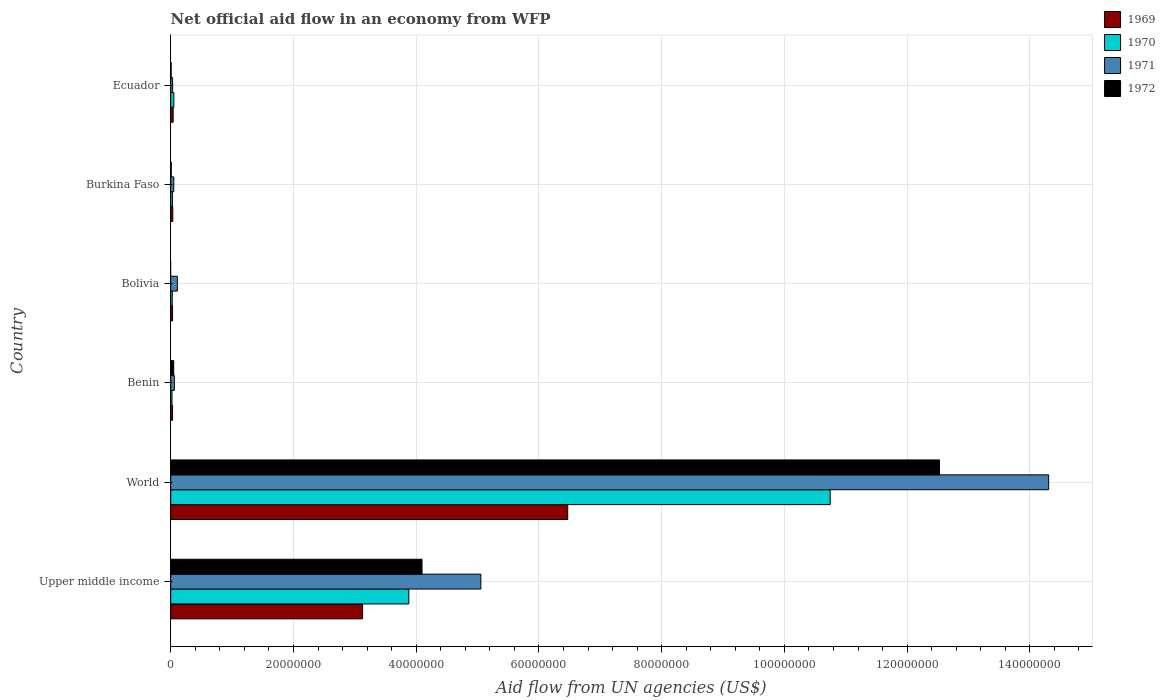Are the number of bars per tick equal to the number of legend labels?
Provide a succinct answer. No. Are the number of bars on each tick of the Y-axis equal?
Make the answer very short. No. How many bars are there on the 4th tick from the top?
Provide a succinct answer. 4. How many bars are there on the 2nd tick from the bottom?
Keep it short and to the point. 4. What is the net official aid flow in 1972 in Burkina Faso?
Give a very brief answer. 9.00e+04. Across all countries, what is the maximum net official aid flow in 1970?
Provide a short and direct response. 1.07e+08. Across all countries, what is the minimum net official aid flow in 1969?
Ensure brevity in your answer.  3.00e+05. What is the total net official aid flow in 1972 in the graph?
Provide a short and direct response. 1.67e+08. What is the difference between the net official aid flow in 1972 in Burkina Faso and that in World?
Your response must be concise. -1.25e+08. What is the difference between the net official aid flow in 1969 in Bolivia and the net official aid flow in 1971 in Burkina Faso?
Your response must be concise. -2.00e+05. What is the average net official aid flow in 1970 per country?
Your answer should be compact. 2.46e+07. In how many countries, is the net official aid flow in 1971 greater than 32000000 US$?
Provide a succinct answer. 2. What is the ratio of the net official aid flow in 1970 in Burkina Faso to that in Ecuador?
Provide a succinct answer. 0.55. Is the net official aid flow in 1970 in Benin less than that in Ecuador?
Your response must be concise. Yes. What is the difference between the highest and the second highest net official aid flow in 1972?
Your answer should be compact. 8.43e+07. What is the difference between the highest and the lowest net official aid flow in 1969?
Make the answer very short. 6.44e+07. Are all the bars in the graph horizontal?
Your response must be concise. Yes. Are the values on the major ticks of X-axis written in scientific E-notation?
Make the answer very short. No. How many legend labels are there?
Keep it short and to the point. 4. What is the title of the graph?
Make the answer very short. Net official aid flow in an economy from WFP. What is the label or title of the X-axis?
Your answer should be compact. Aid flow from UN agencies (US$). What is the label or title of the Y-axis?
Ensure brevity in your answer.  Country. What is the Aid flow from UN agencies (US$) in 1969 in Upper middle income?
Provide a short and direct response. 3.13e+07. What is the Aid flow from UN agencies (US$) of 1970 in Upper middle income?
Your answer should be very brief. 3.88e+07. What is the Aid flow from UN agencies (US$) of 1971 in Upper middle income?
Your answer should be very brief. 5.05e+07. What is the Aid flow from UN agencies (US$) of 1972 in Upper middle income?
Make the answer very short. 4.10e+07. What is the Aid flow from UN agencies (US$) in 1969 in World?
Provide a succinct answer. 6.47e+07. What is the Aid flow from UN agencies (US$) in 1970 in World?
Provide a short and direct response. 1.07e+08. What is the Aid flow from UN agencies (US$) of 1971 in World?
Your answer should be very brief. 1.43e+08. What is the Aid flow from UN agencies (US$) of 1972 in World?
Give a very brief answer. 1.25e+08. What is the Aid flow from UN agencies (US$) in 1969 in Benin?
Offer a very short reply. 3.00e+05. What is the Aid flow from UN agencies (US$) in 1970 in Benin?
Your answer should be very brief. 2.10e+05. What is the Aid flow from UN agencies (US$) of 1971 in Benin?
Your response must be concise. 5.90e+05. What is the Aid flow from UN agencies (US$) of 1969 in Bolivia?
Make the answer very short. 3.00e+05. What is the Aid flow from UN agencies (US$) in 1971 in Bolivia?
Your answer should be compact. 1.08e+06. What is the Aid flow from UN agencies (US$) of 1970 in Burkina Faso?
Offer a very short reply. 2.80e+05. What is the Aid flow from UN agencies (US$) in 1969 in Ecuador?
Make the answer very short. 4.00e+05. What is the Aid flow from UN agencies (US$) of 1970 in Ecuador?
Your answer should be very brief. 5.10e+05. What is the Aid flow from UN agencies (US$) in 1972 in Ecuador?
Your response must be concise. 7.00e+04. Across all countries, what is the maximum Aid flow from UN agencies (US$) in 1969?
Provide a short and direct response. 6.47e+07. Across all countries, what is the maximum Aid flow from UN agencies (US$) in 1970?
Ensure brevity in your answer.  1.07e+08. Across all countries, what is the maximum Aid flow from UN agencies (US$) in 1971?
Provide a succinct answer. 1.43e+08. Across all countries, what is the maximum Aid flow from UN agencies (US$) in 1972?
Your response must be concise. 1.25e+08. Across all countries, what is the minimum Aid flow from UN agencies (US$) in 1969?
Make the answer very short. 3.00e+05. Across all countries, what is the minimum Aid flow from UN agencies (US$) of 1970?
Offer a very short reply. 2.10e+05. Across all countries, what is the minimum Aid flow from UN agencies (US$) of 1971?
Make the answer very short. 3.10e+05. What is the total Aid flow from UN agencies (US$) in 1969 in the graph?
Provide a succinct answer. 9.73e+07. What is the total Aid flow from UN agencies (US$) in 1970 in the graph?
Make the answer very short. 1.48e+08. What is the total Aid flow from UN agencies (US$) of 1971 in the graph?
Give a very brief answer. 1.96e+08. What is the total Aid flow from UN agencies (US$) of 1972 in the graph?
Your response must be concise. 1.67e+08. What is the difference between the Aid flow from UN agencies (US$) in 1969 in Upper middle income and that in World?
Keep it short and to the point. -3.34e+07. What is the difference between the Aid flow from UN agencies (US$) in 1970 in Upper middle income and that in World?
Make the answer very short. -6.87e+07. What is the difference between the Aid flow from UN agencies (US$) of 1971 in Upper middle income and that in World?
Offer a very short reply. -9.25e+07. What is the difference between the Aid flow from UN agencies (US$) of 1972 in Upper middle income and that in World?
Your answer should be compact. -8.43e+07. What is the difference between the Aid flow from UN agencies (US$) of 1969 in Upper middle income and that in Benin?
Your response must be concise. 3.10e+07. What is the difference between the Aid flow from UN agencies (US$) of 1970 in Upper middle income and that in Benin?
Offer a very short reply. 3.86e+07. What is the difference between the Aid flow from UN agencies (US$) in 1971 in Upper middle income and that in Benin?
Your answer should be very brief. 5.00e+07. What is the difference between the Aid flow from UN agencies (US$) of 1972 in Upper middle income and that in Benin?
Your response must be concise. 4.05e+07. What is the difference between the Aid flow from UN agencies (US$) of 1969 in Upper middle income and that in Bolivia?
Make the answer very short. 3.10e+07. What is the difference between the Aid flow from UN agencies (US$) in 1970 in Upper middle income and that in Bolivia?
Your answer should be very brief. 3.86e+07. What is the difference between the Aid flow from UN agencies (US$) in 1971 in Upper middle income and that in Bolivia?
Your answer should be very brief. 4.95e+07. What is the difference between the Aid flow from UN agencies (US$) of 1969 in Upper middle income and that in Burkina Faso?
Make the answer very short. 3.09e+07. What is the difference between the Aid flow from UN agencies (US$) of 1970 in Upper middle income and that in Burkina Faso?
Keep it short and to the point. 3.85e+07. What is the difference between the Aid flow from UN agencies (US$) of 1971 in Upper middle income and that in Burkina Faso?
Offer a very short reply. 5.00e+07. What is the difference between the Aid flow from UN agencies (US$) of 1972 in Upper middle income and that in Burkina Faso?
Ensure brevity in your answer.  4.09e+07. What is the difference between the Aid flow from UN agencies (US$) of 1969 in Upper middle income and that in Ecuador?
Your answer should be very brief. 3.09e+07. What is the difference between the Aid flow from UN agencies (US$) in 1970 in Upper middle income and that in Ecuador?
Offer a terse response. 3.83e+07. What is the difference between the Aid flow from UN agencies (US$) in 1971 in Upper middle income and that in Ecuador?
Make the answer very short. 5.02e+07. What is the difference between the Aid flow from UN agencies (US$) in 1972 in Upper middle income and that in Ecuador?
Provide a short and direct response. 4.09e+07. What is the difference between the Aid flow from UN agencies (US$) of 1969 in World and that in Benin?
Give a very brief answer. 6.44e+07. What is the difference between the Aid flow from UN agencies (US$) in 1970 in World and that in Benin?
Offer a very short reply. 1.07e+08. What is the difference between the Aid flow from UN agencies (US$) of 1971 in World and that in Benin?
Your response must be concise. 1.42e+08. What is the difference between the Aid flow from UN agencies (US$) in 1972 in World and that in Benin?
Give a very brief answer. 1.25e+08. What is the difference between the Aid flow from UN agencies (US$) in 1969 in World and that in Bolivia?
Ensure brevity in your answer.  6.44e+07. What is the difference between the Aid flow from UN agencies (US$) of 1970 in World and that in Bolivia?
Provide a succinct answer. 1.07e+08. What is the difference between the Aid flow from UN agencies (US$) in 1971 in World and that in Bolivia?
Keep it short and to the point. 1.42e+08. What is the difference between the Aid flow from UN agencies (US$) in 1969 in World and that in Burkina Faso?
Your answer should be compact. 6.44e+07. What is the difference between the Aid flow from UN agencies (US$) in 1970 in World and that in Burkina Faso?
Offer a very short reply. 1.07e+08. What is the difference between the Aid flow from UN agencies (US$) in 1971 in World and that in Burkina Faso?
Offer a terse response. 1.43e+08. What is the difference between the Aid flow from UN agencies (US$) of 1972 in World and that in Burkina Faso?
Provide a succinct answer. 1.25e+08. What is the difference between the Aid flow from UN agencies (US$) of 1969 in World and that in Ecuador?
Provide a succinct answer. 6.43e+07. What is the difference between the Aid flow from UN agencies (US$) in 1970 in World and that in Ecuador?
Offer a terse response. 1.07e+08. What is the difference between the Aid flow from UN agencies (US$) of 1971 in World and that in Ecuador?
Ensure brevity in your answer.  1.43e+08. What is the difference between the Aid flow from UN agencies (US$) in 1972 in World and that in Ecuador?
Offer a terse response. 1.25e+08. What is the difference between the Aid flow from UN agencies (US$) of 1970 in Benin and that in Bolivia?
Provide a succinct answer. -4.00e+04. What is the difference between the Aid flow from UN agencies (US$) in 1971 in Benin and that in Bolivia?
Make the answer very short. -4.90e+05. What is the difference between the Aid flow from UN agencies (US$) in 1970 in Benin and that in Burkina Faso?
Make the answer very short. -7.00e+04. What is the difference between the Aid flow from UN agencies (US$) in 1969 in Benin and that in Ecuador?
Your answer should be compact. -1.00e+05. What is the difference between the Aid flow from UN agencies (US$) of 1970 in Benin and that in Ecuador?
Provide a short and direct response. -3.00e+05. What is the difference between the Aid flow from UN agencies (US$) in 1971 in Benin and that in Ecuador?
Offer a very short reply. 2.80e+05. What is the difference between the Aid flow from UN agencies (US$) of 1972 in Benin and that in Ecuador?
Provide a succinct answer. 4.20e+05. What is the difference between the Aid flow from UN agencies (US$) in 1970 in Bolivia and that in Burkina Faso?
Your answer should be compact. -3.00e+04. What is the difference between the Aid flow from UN agencies (US$) of 1971 in Bolivia and that in Burkina Faso?
Provide a succinct answer. 5.80e+05. What is the difference between the Aid flow from UN agencies (US$) in 1969 in Bolivia and that in Ecuador?
Provide a succinct answer. -1.00e+05. What is the difference between the Aid flow from UN agencies (US$) in 1971 in Bolivia and that in Ecuador?
Your answer should be compact. 7.70e+05. What is the difference between the Aid flow from UN agencies (US$) of 1969 in Burkina Faso and that in Ecuador?
Keep it short and to the point. -6.00e+04. What is the difference between the Aid flow from UN agencies (US$) of 1971 in Burkina Faso and that in Ecuador?
Ensure brevity in your answer.  1.90e+05. What is the difference between the Aid flow from UN agencies (US$) of 1969 in Upper middle income and the Aid flow from UN agencies (US$) of 1970 in World?
Your response must be concise. -7.62e+07. What is the difference between the Aid flow from UN agencies (US$) of 1969 in Upper middle income and the Aid flow from UN agencies (US$) of 1971 in World?
Keep it short and to the point. -1.12e+08. What is the difference between the Aid flow from UN agencies (US$) of 1969 in Upper middle income and the Aid flow from UN agencies (US$) of 1972 in World?
Make the answer very short. -9.40e+07. What is the difference between the Aid flow from UN agencies (US$) of 1970 in Upper middle income and the Aid flow from UN agencies (US$) of 1971 in World?
Offer a terse response. -1.04e+08. What is the difference between the Aid flow from UN agencies (US$) in 1970 in Upper middle income and the Aid flow from UN agencies (US$) in 1972 in World?
Give a very brief answer. -8.65e+07. What is the difference between the Aid flow from UN agencies (US$) of 1971 in Upper middle income and the Aid flow from UN agencies (US$) of 1972 in World?
Keep it short and to the point. -7.47e+07. What is the difference between the Aid flow from UN agencies (US$) in 1969 in Upper middle income and the Aid flow from UN agencies (US$) in 1970 in Benin?
Ensure brevity in your answer.  3.10e+07. What is the difference between the Aid flow from UN agencies (US$) in 1969 in Upper middle income and the Aid flow from UN agencies (US$) in 1971 in Benin?
Ensure brevity in your answer.  3.07e+07. What is the difference between the Aid flow from UN agencies (US$) in 1969 in Upper middle income and the Aid flow from UN agencies (US$) in 1972 in Benin?
Make the answer very short. 3.08e+07. What is the difference between the Aid flow from UN agencies (US$) of 1970 in Upper middle income and the Aid flow from UN agencies (US$) of 1971 in Benin?
Provide a succinct answer. 3.82e+07. What is the difference between the Aid flow from UN agencies (US$) in 1970 in Upper middle income and the Aid flow from UN agencies (US$) in 1972 in Benin?
Give a very brief answer. 3.83e+07. What is the difference between the Aid flow from UN agencies (US$) in 1971 in Upper middle income and the Aid flow from UN agencies (US$) in 1972 in Benin?
Offer a terse response. 5.00e+07. What is the difference between the Aid flow from UN agencies (US$) of 1969 in Upper middle income and the Aid flow from UN agencies (US$) of 1970 in Bolivia?
Ensure brevity in your answer.  3.10e+07. What is the difference between the Aid flow from UN agencies (US$) of 1969 in Upper middle income and the Aid flow from UN agencies (US$) of 1971 in Bolivia?
Keep it short and to the point. 3.02e+07. What is the difference between the Aid flow from UN agencies (US$) of 1970 in Upper middle income and the Aid flow from UN agencies (US$) of 1971 in Bolivia?
Make the answer very short. 3.77e+07. What is the difference between the Aid flow from UN agencies (US$) in 1969 in Upper middle income and the Aid flow from UN agencies (US$) in 1970 in Burkina Faso?
Provide a succinct answer. 3.10e+07. What is the difference between the Aid flow from UN agencies (US$) in 1969 in Upper middle income and the Aid flow from UN agencies (US$) in 1971 in Burkina Faso?
Give a very brief answer. 3.08e+07. What is the difference between the Aid flow from UN agencies (US$) in 1969 in Upper middle income and the Aid flow from UN agencies (US$) in 1972 in Burkina Faso?
Give a very brief answer. 3.12e+07. What is the difference between the Aid flow from UN agencies (US$) in 1970 in Upper middle income and the Aid flow from UN agencies (US$) in 1971 in Burkina Faso?
Your answer should be compact. 3.83e+07. What is the difference between the Aid flow from UN agencies (US$) in 1970 in Upper middle income and the Aid flow from UN agencies (US$) in 1972 in Burkina Faso?
Your answer should be very brief. 3.87e+07. What is the difference between the Aid flow from UN agencies (US$) of 1971 in Upper middle income and the Aid flow from UN agencies (US$) of 1972 in Burkina Faso?
Provide a short and direct response. 5.04e+07. What is the difference between the Aid flow from UN agencies (US$) of 1969 in Upper middle income and the Aid flow from UN agencies (US$) of 1970 in Ecuador?
Make the answer very short. 3.08e+07. What is the difference between the Aid flow from UN agencies (US$) of 1969 in Upper middle income and the Aid flow from UN agencies (US$) of 1971 in Ecuador?
Make the answer very short. 3.10e+07. What is the difference between the Aid flow from UN agencies (US$) of 1969 in Upper middle income and the Aid flow from UN agencies (US$) of 1972 in Ecuador?
Offer a terse response. 3.12e+07. What is the difference between the Aid flow from UN agencies (US$) in 1970 in Upper middle income and the Aid flow from UN agencies (US$) in 1971 in Ecuador?
Offer a very short reply. 3.85e+07. What is the difference between the Aid flow from UN agencies (US$) in 1970 in Upper middle income and the Aid flow from UN agencies (US$) in 1972 in Ecuador?
Make the answer very short. 3.87e+07. What is the difference between the Aid flow from UN agencies (US$) in 1971 in Upper middle income and the Aid flow from UN agencies (US$) in 1972 in Ecuador?
Give a very brief answer. 5.05e+07. What is the difference between the Aid flow from UN agencies (US$) of 1969 in World and the Aid flow from UN agencies (US$) of 1970 in Benin?
Ensure brevity in your answer.  6.45e+07. What is the difference between the Aid flow from UN agencies (US$) in 1969 in World and the Aid flow from UN agencies (US$) in 1971 in Benin?
Your response must be concise. 6.41e+07. What is the difference between the Aid flow from UN agencies (US$) of 1969 in World and the Aid flow from UN agencies (US$) of 1972 in Benin?
Offer a terse response. 6.42e+07. What is the difference between the Aid flow from UN agencies (US$) of 1970 in World and the Aid flow from UN agencies (US$) of 1971 in Benin?
Provide a succinct answer. 1.07e+08. What is the difference between the Aid flow from UN agencies (US$) in 1970 in World and the Aid flow from UN agencies (US$) in 1972 in Benin?
Make the answer very short. 1.07e+08. What is the difference between the Aid flow from UN agencies (US$) of 1971 in World and the Aid flow from UN agencies (US$) of 1972 in Benin?
Your response must be concise. 1.43e+08. What is the difference between the Aid flow from UN agencies (US$) in 1969 in World and the Aid flow from UN agencies (US$) in 1970 in Bolivia?
Give a very brief answer. 6.44e+07. What is the difference between the Aid flow from UN agencies (US$) in 1969 in World and the Aid flow from UN agencies (US$) in 1971 in Bolivia?
Provide a short and direct response. 6.36e+07. What is the difference between the Aid flow from UN agencies (US$) of 1970 in World and the Aid flow from UN agencies (US$) of 1971 in Bolivia?
Keep it short and to the point. 1.06e+08. What is the difference between the Aid flow from UN agencies (US$) of 1969 in World and the Aid flow from UN agencies (US$) of 1970 in Burkina Faso?
Keep it short and to the point. 6.44e+07. What is the difference between the Aid flow from UN agencies (US$) in 1969 in World and the Aid flow from UN agencies (US$) in 1971 in Burkina Faso?
Offer a very short reply. 6.42e+07. What is the difference between the Aid flow from UN agencies (US$) of 1969 in World and the Aid flow from UN agencies (US$) of 1972 in Burkina Faso?
Give a very brief answer. 6.46e+07. What is the difference between the Aid flow from UN agencies (US$) of 1970 in World and the Aid flow from UN agencies (US$) of 1971 in Burkina Faso?
Give a very brief answer. 1.07e+08. What is the difference between the Aid flow from UN agencies (US$) of 1970 in World and the Aid flow from UN agencies (US$) of 1972 in Burkina Faso?
Ensure brevity in your answer.  1.07e+08. What is the difference between the Aid flow from UN agencies (US$) in 1971 in World and the Aid flow from UN agencies (US$) in 1972 in Burkina Faso?
Provide a succinct answer. 1.43e+08. What is the difference between the Aid flow from UN agencies (US$) in 1969 in World and the Aid flow from UN agencies (US$) in 1970 in Ecuador?
Your answer should be compact. 6.42e+07. What is the difference between the Aid flow from UN agencies (US$) of 1969 in World and the Aid flow from UN agencies (US$) of 1971 in Ecuador?
Your answer should be very brief. 6.44e+07. What is the difference between the Aid flow from UN agencies (US$) of 1969 in World and the Aid flow from UN agencies (US$) of 1972 in Ecuador?
Your answer should be very brief. 6.46e+07. What is the difference between the Aid flow from UN agencies (US$) of 1970 in World and the Aid flow from UN agencies (US$) of 1971 in Ecuador?
Provide a short and direct response. 1.07e+08. What is the difference between the Aid flow from UN agencies (US$) in 1970 in World and the Aid flow from UN agencies (US$) in 1972 in Ecuador?
Your answer should be very brief. 1.07e+08. What is the difference between the Aid flow from UN agencies (US$) of 1971 in World and the Aid flow from UN agencies (US$) of 1972 in Ecuador?
Your answer should be compact. 1.43e+08. What is the difference between the Aid flow from UN agencies (US$) of 1969 in Benin and the Aid flow from UN agencies (US$) of 1970 in Bolivia?
Offer a very short reply. 5.00e+04. What is the difference between the Aid flow from UN agencies (US$) of 1969 in Benin and the Aid flow from UN agencies (US$) of 1971 in Bolivia?
Your answer should be very brief. -7.80e+05. What is the difference between the Aid flow from UN agencies (US$) of 1970 in Benin and the Aid flow from UN agencies (US$) of 1971 in Bolivia?
Provide a short and direct response. -8.70e+05. What is the difference between the Aid flow from UN agencies (US$) in 1969 in Benin and the Aid flow from UN agencies (US$) in 1971 in Burkina Faso?
Ensure brevity in your answer.  -2.00e+05. What is the difference between the Aid flow from UN agencies (US$) in 1971 in Benin and the Aid flow from UN agencies (US$) in 1972 in Burkina Faso?
Provide a succinct answer. 5.00e+05. What is the difference between the Aid flow from UN agencies (US$) of 1969 in Benin and the Aid flow from UN agencies (US$) of 1970 in Ecuador?
Ensure brevity in your answer.  -2.10e+05. What is the difference between the Aid flow from UN agencies (US$) in 1971 in Benin and the Aid flow from UN agencies (US$) in 1972 in Ecuador?
Offer a very short reply. 5.20e+05. What is the difference between the Aid flow from UN agencies (US$) of 1969 in Bolivia and the Aid flow from UN agencies (US$) of 1972 in Burkina Faso?
Your response must be concise. 2.10e+05. What is the difference between the Aid flow from UN agencies (US$) in 1970 in Bolivia and the Aid flow from UN agencies (US$) in 1972 in Burkina Faso?
Make the answer very short. 1.60e+05. What is the difference between the Aid flow from UN agencies (US$) of 1971 in Bolivia and the Aid flow from UN agencies (US$) of 1972 in Burkina Faso?
Make the answer very short. 9.90e+05. What is the difference between the Aid flow from UN agencies (US$) of 1969 in Bolivia and the Aid flow from UN agencies (US$) of 1970 in Ecuador?
Offer a terse response. -2.10e+05. What is the difference between the Aid flow from UN agencies (US$) of 1969 in Bolivia and the Aid flow from UN agencies (US$) of 1971 in Ecuador?
Your answer should be very brief. -10000. What is the difference between the Aid flow from UN agencies (US$) in 1970 in Bolivia and the Aid flow from UN agencies (US$) in 1971 in Ecuador?
Keep it short and to the point. -6.00e+04. What is the difference between the Aid flow from UN agencies (US$) in 1971 in Bolivia and the Aid flow from UN agencies (US$) in 1972 in Ecuador?
Give a very brief answer. 1.01e+06. What is the difference between the Aid flow from UN agencies (US$) in 1969 in Burkina Faso and the Aid flow from UN agencies (US$) in 1970 in Ecuador?
Make the answer very short. -1.70e+05. What is the difference between the Aid flow from UN agencies (US$) in 1969 in Burkina Faso and the Aid flow from UN agencies (US$) in 1972 in Ecuador?
Keep it short and to the point. 2.70e+05. What is the difference between the Aid flow from UN agencies (US$) in 1971 in Burkina Faso and the Aid flow from UN agencies (US$) in 1972 in Ecuador?
Provide a succinct answer. 4.30e+05. What is the average Aid flow from UN agencies (US$) of 1969 per country?
Give a very brief answer. 1.62e+07. What is the average Aid flow from UN agencies (US$) in 1970 per country?
Provide a succinct answer. 2.46e+07. What is the average Aid flow from UN agencies (US$) in 1971 per country?
Your response must be concise. 3.27e+07. What is the average Aid flow from UN agencies (US$) in 1972 per country?
Keep it short and to the point. 2.78e+07. What is the difference between the Aid flow from UN agencies (US$) in 1969 and Aid flow from UN agencies (US$) in 1970 in Upper middle income?
Offer a very short reply. -7.54e+06. What is the difference between the Aid flow from UN agencies (US$) of 1969 and Aid flow from UN agencies (US$) of 1971 in Upper middle income?
Provide a succinct answer. -1.93e+07. What is the difference between the Aid flow from UN agencies (US$) in 1969 and Aid flow from UN agencies (US$) in 1972 in Upper middle income?
Your answer should be compact. -9.69e+06. What is the difference between the Aid flow from UN agencies (US$) in 1970 and Aid flow from UN agencies (US$) in 1971 in Upper middle income?
Give a very brief answer. -1.17e+07. What is the difference between the Aid flow from UN agencies (US$) in 1970 and Aid flow from UN agencies (US$) in 1972 in Upper middle income?
Ensure brevity in your answer.  -2.15e+06. What is the difference between the Aid flow from UN agencies (US$) of 1971 and Aid flow from UN agencies (US$) of 1972 in Upper middle income?
Your answer should be very brief. 9.59e+06. What is the difference between the Aid flow from UN agencies (US$) of 1969 and Aid flow from UN agencies (US$) of 1970 in World?
Provide a succinct answer. -4.28e+07. What is the difference between the Aid flow from UN agencies (US$) of 1969 and Aid flow from UN agencies (US$) of 1971 in World?
Provide a succinct answer. -7.84e+07. What is the difference between the Aid flow from UN agencies (US$) in 1969 and Aid flow from UN agencies (US$) in 1972 in World?
Make the answer very short. -6.06e+07. What is the difference between the Aid flow from UN agencies (US$) of 1970 and Aid flow from UN agencies (US$) of 1971 in World?
Offer a very short reply. -3.56e+07. What is the difference between the Aid flow from UN agencies (US$) in 1970 and Aid flow from UN agencies (US$) in 1972 in World?
Give a very brief answer. -1.78e+07. What is the difference between the Aid flow from UN agencies (US$) in 1971 and Aid flow from UN agencies (US$) in 1972 in World?
Keep it short and to the point. 1.78e+07. What is the difference between the Aid flow from UN agencies (US$) of 1969 and Aid flow from UN agencies (US$) of 1972 in Benin?
Your answer should be compact. -1.90e+05. What is the difference between the Aid flow from UN agencies (US$) of 1970 and Aid flow from UN agencies (US$) of 1971 in Benin?
Make the answer very short. -3.80e+05. What is the difference between the Aid flow from UN agencies (US$) of 1970 and Aid flow from UN agencies (US$) of 1972 in Benin?
Your answer should be compact. -2.80e+05. What is the difference between the Aid flow from UN agencies (US$) of 1969 and Aid flow from UN agencies (US$) of 1971 in Bolivia?
Offer a very short reply. -7.80e+05. What is the difference between the Aid flow from UN agencies (US$) of 1970 and Aid flow from UN agencies (US$) of 1971 in Bolivia?
Give a very brief answer. -8.30e+05. What is the difference between the Aid flow from UN agencies (US$) in 1969 and Aid flow from UN agencies (US$) in 1970 in Burkina Faso?
Offer a terse response. 6.00e+04. What is the difference between the Aid flow from UN agencies (US$) in 1969 and Aid flow from UN agencies (US$) in 1972 in Burkina Faso?
Your response must be concise. 2.50e+05. What is the difference between the Aid flow from UN agencies (US$) in 1969 and Aid flow from UN agencies (US$) in 1970 in Ecuador?
Offer a very short reply. -1.10e+05. What is the difference between the Aid flow from UN agencies (US$) of 1969 and Aid flow from UN agencies (US$) of 1972 in Ecuador?
Keep it short and to the point. 3.30e+05. What is the difference between the Aid flow from UN agencies (US$) of 1970 and Aid flow from UN agencies (US$) of 1972 in Ecuador?
Your response must be concise. 4.40e+05. What is the difference between the Aid flow from UN agencies (US$) in 1971 and Aid flow from UN agencies (US$) in 1972 in Ecuador?
Provide a succinct answer. 2.40e+05. What is the ratio of the Aid flow from UN agencies (US$) in 1969 in Upper middle income to that in World?
Ensure brevity in your answer.  0.48. What is the ratio of the Aid flow from UN agencies (US$) in 1970 in Upper middle income to that in World?
Make the answer very short. 0.36. What is the ratio of the Aid flow from UN agencies (US$) of 1971 in Upper middle income to that in World?
Your answer should be very brief. 0.35. What is the ratio of the Aid flow from UN agencies (US$) in 1972 in Upper middle income to that in World?
Your answer should be compact. 0.33. What is the ratio of the Aid flow from UN agencies (US$) of 1969 in Upper middle income to that in Benin?
Provide a short and direct response. 104.2. What is the ratio of the Aid flow from UN agencies (US$) in 1970 in Upper middle income to that in Benin?
Give a very brief answer. 184.76. What is the ratio of the Aid flow from UN agencies (US$) in 1971 in Upper middle income to that in Benin?
Your answer should be very brief. 85.66. What is the ratio of the Aid flow from UN agencies (US$) of 1972 in Upper middle income to that in Benin?
Offer a terse response. 83.57. What is the ratio of the Aid flow from UN agencies (US$) in 1969 in Upper middle income to that in Bolivia?
Your answer should be very brief. 104.2. What is the ratio of the Aid flow from UN agencies (US$) of 1970 in Upper middle income to that in Bolivia?
Keep it short and to the point. 155.2. What is the ratio of the Aid flow from UN agencies (US$) of 1971 in Upper middle income to that in Bolivia?
Offer a terse response. 46.8. What is the ratio of the Aid flow from UN agencies (US$) of 1969 in Upper middle income to that in Burkina Faso?
Your response must be concise. 91.94. What is the ratio of the Aid flow from UN agencies (US$) of 1970 in Upper middle income to that in Burkina Faso?
Ensure brevity in your answer.  138.57. What is the ratio of the Aid flow from UN agencies (US$) in 1971 in Upper middle income to that in Burkina Faso?
Keep it short and to the point. 101.08. What is the ratio of the Aid flow from UN agencies (US$) in 1972 in Upper middle income to that in Burkina Faso?
Your response must be concise. 455. What is the ratio of the Aid flow from UN agencies (US$) in 1969 in Upper middle income to that in Ecuador?
Provide a succinct answer. 78.15. What is the ratio of the Aid flow from UN agencies (US$) of 1970 in Upper middle income to that in Ecuador?
Ensure brevity in your answer.  76.08. What is the ratio of the Aid flow from UN agencies (US$) in 1971 in Upper middle income to that in Ecuador?
Your answer should be very brief. 163.03. What is the ratio of the Aid flow from UN agencies (US$) in 1972 in Upper middle income to that in Ecuador?
Provide a succinct answer. 585. What is the ratio of the Aid flow from UN agencies (US$) of 1969 in World to that in Benin?
Your response must be concise. 215.63. What is the ratio of the Aid flow from UN agencies (US$) of 1970 in World to that in Benin?
Provide a short and direct response. 511.71. What is the ratio of the Aid flow from UN agencies (US$) in 1971 in World to that in Benin?
Provide a short and direct response. 242.47. What is the ratio of the Aid flow from UN agencies (US$) in 1972 in World to that in Benin?
Provide a short and direct response. 255.65. What is the ratio of the Aid flow from UN agencies (US$) in 1969 in World to that in Bolivia?
Provide a succinct answer. 215.63. What is the ratio of the Aid flow from UN agencies (US$) of 1970 in World to that in Bolivia?
Offer a terse response. 429.84. What is the ratio of the Aid flow from UN agencies (US$) in 1971 in World to that in Bolivia?
Keep it short and to the point. 132.46. What is the ratio of the Aid flow from UN agencies (US$) in 1969 in World to that in Burkina Faso?
Offer a terse response. 190.26. What is the ratio of the Aid flow from UN agencies (US$) in 1970 in World to that in Burkina Faso?
Make the answer very short. 383.79. What is the ratio of the Aid flow from UN agencies (US$) of 1971 in World to that in Burkina Faso?
Keep it short and to the point. 286.12. What is the ratio of the Aid flow from UN agencies (US$) in 1972 in World to that in Burkina Faso?
Offer a terse response. 1391.89. What is the ratio of the Aid flow from UN agencies (US$) of 1969 in World to that in Ecuador?
Offer a very short reply. 161.72. What is the ratio of the Aid flow from UN agencies (US$) in 1970 in World to that in Ecuador?
Provide a succinct answer. 210.71. What is the ratio of the Aid flow from UN agencies (US$) in 1971 in World to that in Ecuador?
Your answer should be compact. 461.48. What is the ratio of the Aid flow from UN agencies (US$) of 1972 in World to that in Ecuador?
Keep it short and to the point. 1789.57. What is the ratio of the Aid flow from UN agencies (US$) in 1970 in Benin to that in Bolivia?
Provide a succinct answer. 0.84. What is the ratio of the Aid flow from UN agencies (US$) of 1971 in Benin to that in Bolivia?
Give a very brief answer. 0.55. What is the ratio of the Aid flow from UN agencies (US$) in 1969 in Benin to that in Burkina Faso?
Offer a terse response. 0.88. What is the ratio of the Aid flow from UN agencies (US$) of 1970 in Benin to that in Burkina Faso?
Keep it short and to the point. 0.75. What is the ratio of the Aid flow from UN agencies (US$) of 1971 in Benin to that in Burkina Faso?
Provide a succinct answer. 1.18. What is the ratio of the Aid flow from UN agencies (US$) in 1972 in Benin to that in Burkina Faso?
Provide a succinct answer. 5.44. What is the ratio of the Aid flow from UN agencies (US$) in 1969 in Benin to that in Ecuador?
Give a very brief answer. 0.75. What is the ratio of the Aid flow from UN agencies (US$) in 1970 in Benin to that in Ecuador?
Provide a short and direct response. 0.41. What is the ratio of the Aid flow from UN agencies (US$) of 1971 in Benin to that in Ecuador?
Provide a succinct answer. 1.9. What is the ratio of the Aid flow from UN agencies (US$) in 1972 in Benin to that in Ecuador?
Provide a short and direct response. 7. What is the ratio of the Aid flow from UN agencies (US$) of 1969 in Bolivia to that in Burkina Faso?
Offer a very short reply. 0.88. What is the ratio of the Aid flow from UN agencies (US$) in 1970 in Bolivia to that in Burkina Faso?
Provide a short and direct response. 0.89. What is the ratio of the Aid flow from UN agencies (US$) in 1971 in Bolivia to that in Burkina Faso?
Make the answer very short. 2.16. What is the ratio of the Aid flow from UN agencies (US$) of 1969 in Bolivia to that in Ecuador?
Your answer should be very brief. 0.75. What is the ratio of the Aid flow from UN agencies (US$) of 1970 in Bolivia to that in Ecuador?
Your answer should be very brief. 0.49. What is the ratio of the Aid flow from UN agencies (US$) in 1971 in Bolivia to that in Ecuador?
Provide a short and direct response. 3.48. What is the ratio of the Aid flow from UN agencies (US$) in 1969 in Burkina Faso to that in Ecuador?
Give a very brief answer. 0.85. What is the ratio of the Aid flow from UN agencies (US$) of 1970 in Burkina Faso to that in Ecuador?
Ensure brevity in your answer.  0.55. What is the ratio of the Aid flow from UN agencies (US$) in 1971 in Burkina Faso to that in Ecuador?
Offer a very short reply. 1.61. What is the difference between the highest and the second highest Aid flow from UN agencies (US$) of 1969?
Make the answer very short. 3.34e+07. What is the difference between the highest and the second highest Aid flow from UN agencies (US$) in 1970?
Give a very brief answer. 6.87e+07. What is the difference between the highest and the second highest Aid flow from UN agencies (US$) in 1971?
Your answer should be compact. 9.25e+07. What is the difference between the highest and the second highest Aid flow from UN agencies (US$) of 1972?
Your answer should be compact. 8.43e+07. What is the difference between the highest and the lowest Aid flow from UN agencies (US$) in 1969?
Provide a succinct answer. 6.44e+07. What is the difference between the highest and the lowest Aid flow from UN agencies (US$) in 1970?
Your response must be concise. 1.07e+08. What is the difference between the highest and the lowest Aid flow from UN agencies (US$) in 1971?
Offer a very short reply. 1.43e+08. What is the difference between the highest and the lowest Aid flow from UN agencies (US$) in 1972?
Ensure brevity in your answer.  1.25e+08. 